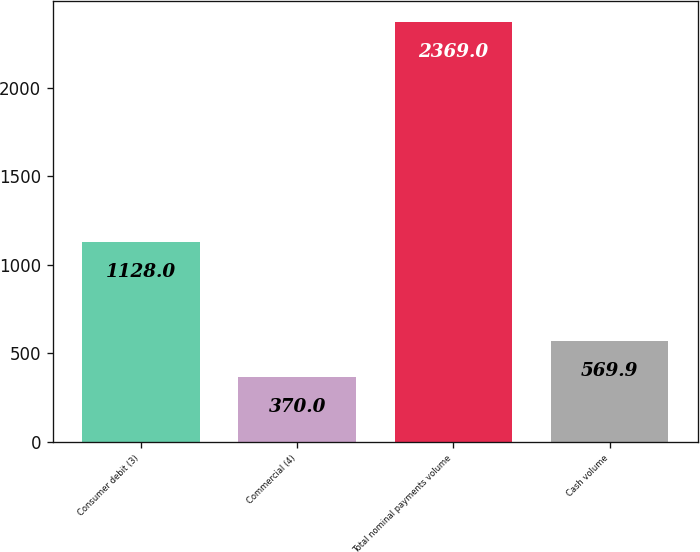Convert chart to OTSL. <chart><loc_0><loc_0><loc_500><loc_500><bar_chart><fcel>Consumer debit (3)<fcel>Commercial (4)<fcel>Total nominal payments volume<fcel>Cash volume<nl><fcel>1128<fcel>370<fcel>2369<fcel>569.9<nl></chart> 